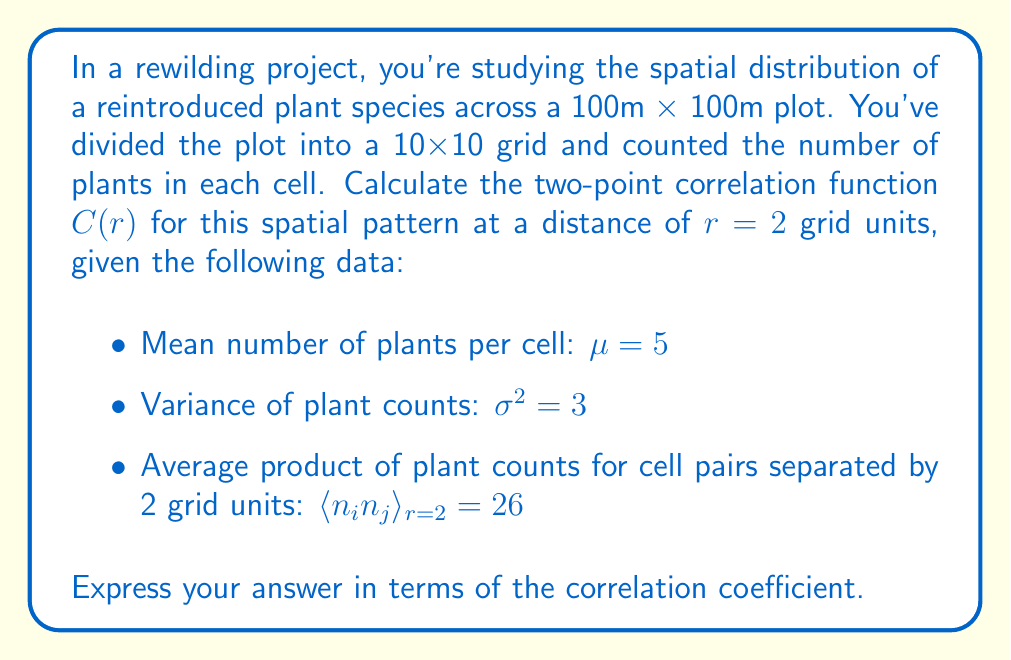Can you solve this math problem? To solve this problem, we'll follow these steps:

1) The two-point correlation function $C(r)$ is defined as:

   $$C(r) = \frac{\langle n_i n_j \rangle_r - \mu^2}{\sigma^2}$$

   where $\langle n_i n_j \rangle_r$ is the average product of plant counts for cell pairs separated by distance $r$, $\mu$ is the mean number of plants per cell, and $\sigma^2$ is the variance of plant counts.

2) We're given:
   - $\mu = 5$
   - $\sigma^2 = 3$
   - $\langle n_i n_j \rangle_{r=2} = 26$
   - $r = 2$ grid units

3) Let's substitute these values into the correlation function equation:

   $$C(2) = \frac{26 - 5^2}{3}$$

4) Simplify:
   $$C(2) = \frac{26 - 25}{3} = \frac{1}{3}$$

5) The correlation coefficient is typically denoted as $\rho$, so we can express our final answer as:

   $$C(2) = \rho = \frac{1}{3}$$

This result indicates a positive spatial correlation at a distance of 2 grid units, suggesting that plants tend to cluster at this scale in the recovering ecosystem.
Answer: $\rho = \frac{1}{3}$ 